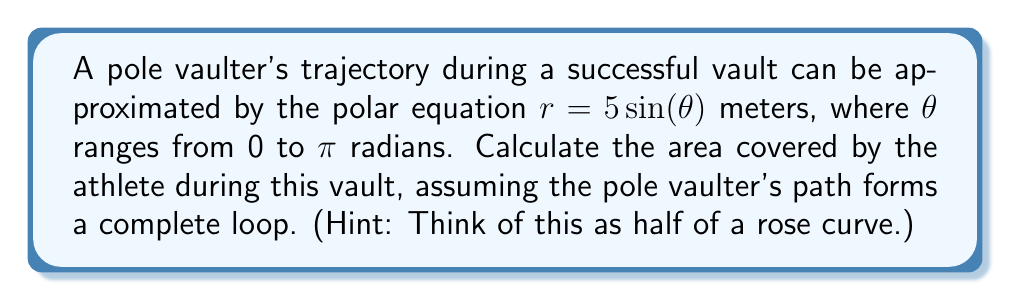Provide a solution to this math problem. To solve this problem, we'll use polar integration to calculate the area enclosed by the curve. Here's a step-by-step approach:

1) The general formula for the area enclosed by a polar curve is:

   $$A = \frac{1}{2} \int_{a}^{b} r^2 d\theta$$

2) In this case, $r = 5\sin(\theta)$ and $\theta$ ranges from 0 to $\pi$. Substituting these into the formula:

   $$A = \frac{1}{2} \int_{0}^{\pi} (5\sin(\theta))^2 d\theta$$

3) Simplify the integrand:

   $$A = \frac{1}{2} \int_{0}^{\pi} 25\sin^2(\theta) d\theta$$

4) Use the trigonometric identity $\sin^2(\theta) = \frac{1 - \cos(2\theta)}{2}$:

   $$A = \frac{1}{2} \int_{0}^{\pi} 25 \cdot \frac{1 - \cos(2\theta)}{2} d\theta$$

5) Simplify:

   $$A = \frac{25}{4} \int_{0}^{\pi} (1 - \cos(2\theta)) d\theta$$

6) Integrate:

   $$A = \frac{25}{4} [\theta - \frac{1}{2}\sin(2\theta)]_{0}^{\pi}$$

7) Evaluate the integral:

   $$A = \frac{25}{4} [(\pi - 0) - (\frac{1}{2}\sin(2\pi) - \frac{1}{2}\sin(0))]$$

8) Simplify:

   $$A = \frac{25}{4} \pi$$

9) Calculate the final result:

   $$A = 19.63 \text{ square meters}$$
Answer: The area covered by the athlete during the pole vault is $\frac{25\pi}{4}$ square meters, or approximately 19.63 square meters. 